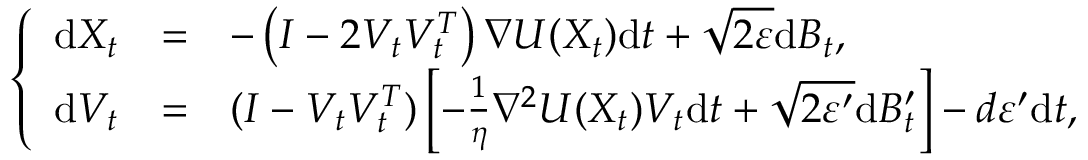<formula> <loc_0><loc_0><loc_500><loc_500>\left \{ \begin{array} { l l l } { d X _ { t } } & { = } & { - \left ( I - 2 V _ { t } V _ { t } ^ { T } \right ) \nabla U ( X _ { t } ) d t + \sqrt { 2 \varepsilon } d B _ { t } , } \\ { d V _ { t } } & { = } & { ( I - V _ { t } V _ { t } ^ { T } ) \left [ - \frac { 1 } \eta \nabla ^ { 2 } U ( X _ { t } ) V _ { t } d t + \sqrt { 2 \varepsilon ^ { \prime } } d B _ { t } ^ { \prime } \right ] - d \varepsilon ^ { \prime } d t , } \end{array}</formula> 